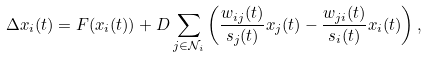Convert formula to latex. <formula><loc_0><loc_0><loc_500><loc_500>\Delta x _ { i } ( t ) = F ( x _ { i } ( t ) ) + D \sum _ { j \in { \mathcal { N } } _ { i } } \left ( \frac { w _ { i j } ( t ) } { s _ { j } ( t ) } x _ { j } ( t ) - \frac { w _ { j i } ( t ) } { s _ { i } ( t ) } x _ { i } ( t ) \right ) ,</formula> 